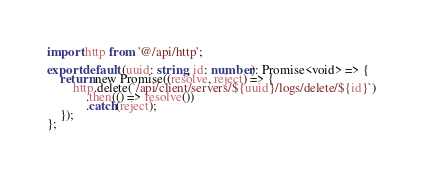Convert code to text. <code><loc_0><loc_0><loc_500><loc_500><_TypeScript_>import http from '@/api/http';

export default (uuid: string, id: number): Promise<void> => {
    return new Promise((resolve, reject) => {
        http.delete(`/api/client/servers/${uuid}/logs/delete/${id}`)
            .then(() => resolve())
            .catch(reject);
    });
};
</code> 